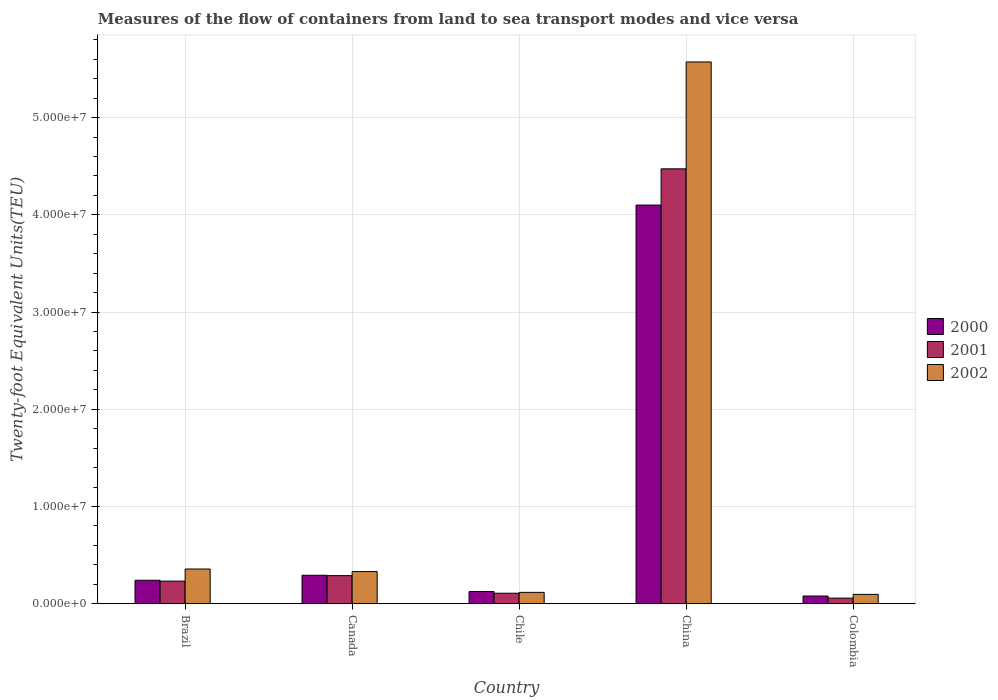Are the number of bars per tick equal to the number of legend labels?
Make the answer very short. Yes. How many bars are there on the 1st tick from the right?
Give a very brief answer. 3. What is the label of the 2nd group of bars from the left?
Keep it short and to the point. Canada. In how many cases, is the number of bars for a given country not equal to the number of legend labels?
Ensure brevity in your answer.  0. What is the container port traffic in 2000 in Brazil?
Provide a succinct answer. 2.41e+06. Across all countries, what is the maximum container port traffic in 2001?
Your answer should be compact. 4.47e+07. Across all countries, what is the minimum container port traffic in 2001?
Offer a terse response. 5.77e+05. In which country was the container port traffic in 2002 maximum?
Ensure brevity in your answer.  China. In which country was the container port traffic in 2002 minimum?
Your response must be concise. Colombia. What is the total container port traffic in 2002 in the graph?
Offer a terse response. 6.47e+07. What is the difference between the container port traffic in 2000 in China and that in Colombia?
Your answer should be very brief. 4.02e+07. What is the difference between the container port traffic in 2001 in Colombia and the container port traffic in 2000 in Chile?
Give a very brief answer. -6.76e+05. What is the average container port traffic in 2002 per country?
Give a very brief answer. 1.29e+07. What is the difference between the container port traffic of/in 2000 and container port traffic of/in 2001 in China?
Ensure brevity in your answer.  -3.73e+06. What is the ratio of the container port traffic in 2001 in Canada to that in Chile?
Your answer should be compact. 2.67. Is the difference between the container port traffic in 2000 in Chile and Colombia greater than the difference between the container port traffic in 2001 in Chile and Colombia?
Your answer should be very brief. No. What is the difference between the highest and the second highest container port traffic in 2000?
Your response must be concise. 3.86e+07. What is the difference between the highest and the lowest container port traffic in 2002?
Give a very brief answer. 5.48e+07. In how many countries, is the container port traffic in 2002 greater than the average container port traffic in 2002 taken over all countries?
Make the answer very short. 1. Is the sum of the container port traffic in 2000 in Chile and Colombia greater than the maximum container port traffic in 2001 across all countries?
Your answer should be very brief. No. Is it the case that in every country, the sum of the container port traffic in 2002 and container port traffic in 2000 is greater than the container port traffic in 2001?
Your response must be concise. Yes. How many bars are there?
Your response must be concise. 15. Are all the bars in the graph horizontal?
Give a very brief answer. No. How many countries are there in the graph?
Your answer should be compact. 5. Are the values on the major ticks of Y-axis written in scientific E-notation?
Give a very brief answer. Yes. How many legend labels are there?
Keep it short and to the point. 3. What is the title of the graph?
Provide a succinct answer. Measures of the flow of containers from land to sea transport modes and vice versa. Does "1984" appear as one of the legend labels in the graph?
Provide a short and direct response. No. What is the label or title of the Y-axis?
Offer a terse response. Twenty-foot Equivalent Units(TEU). What is the Twenty-foot Equivalent Units(TEU) of 2000 in Brazil?
Your answer should be very brief. 2.41e+06. What is the Twenty-foot Equivalent Units(TEU) in 2001 in Brazil?
Ensure brevity in your answer.  2.32e+06. What is the Twenty-foot Equivalent Units(TEU) of 2002 in Brazil?
Your answer should be very brief. 3.57e+06. What is the Twenty-foot Equivalent Units(TEU) of 2000 in Canada?
Your response must be concise. 2.93e+06. What is the Twenty-foot Equivalent Units(TEU) of 2001 in Canada?
Give a very brief answer. 2.89e+06. What is the Twenty-foot Equivalent Units(TEU) in 2002 in Canada?
Offer a terse response. 3.31e+06. What is the Twenty-foot Equivalent Units(TEU) of 2000 in Chile?
Keep it short and to the point. 1.25e+06. What is the Twenty-foot Equivalent Units(TEU) in 2001 in Chile?
Give a very brief answer. 1.08e+06. What is the Twenty-foot Equivalent Units(TEU) of 2002 in Chile?
Provide a short and direct response. 1.17e+06. What is the Twenty-foot Equivalent Units(TEU) of 2000 in China?
Make the answer very short. 4.10e+07. What is the Twenty-foot Equivalent Units(TEU) of 2001 in China?
Offer a very short reply. 4.47e+07. What is the Twenty-foot Equivalent Units(TEU) of 2002 in China?
Your answer should be very brief. 5.57e+07. What is the Twenty-foot Equivalent Units(TEU) of 2000 in Colombia?
Your answer should be very brief. 7.92e+05. What is the Twenty-foot Equivalent Units(TEU) of 2001 in Colombia?
Offer a very short reply. 5.77e+05. What is the Twenty-foot Equivalent Units(TEU) of 2002 in Colombia?
Provide a succinct answer. 9.61e+05. Across all countries, what is the maximum Twenty-foot Equivalent Units(TEU) of 2000?
Keep it short and to the point. 4.10e+07. Across all countries, what is the maximum Twenty-foot Equivalent Units(TEU) in 2001?
Offer a terse response. 4.47e+07. Across all countries, what is the maximum Twenty-foot Equivalent Units(TEU) of 2002?
Offer a very short reply. 5.57e+07. Across all countries, what is the minimum Twenty-foot Equivalent Units(TEU) of 2000?
Your response must be concise. 7.92e+05. Across all countries, what is the minimum Twenty-foot Equivalent Units(TEU) of 2001?
Your response must be concise. 5.77e+05. Across all countries, what is the minimum Twenty-foot Equivalent Units(TEU) of 2002?
Make the answer very short. 9.61e+05. What is the total Twenty-foot Equivalent Units(TEU) in 2000 in the graph?
Offer a very short reply. 4.84e+07. What is the total Twenty-foot Equivalent Units(TEU) of 2001 in the graph?
Provide a succinct answer. 5.16e+07. What is the total Twenty-foot Equivalent Units(TEU) in 2002 in the graph?
Give a very brief answer. 6.47e+07. What is the difference between the Twenty-foot Equivalent Units(TEU) in 2000 in Brazil and that in Canada?
Your answer should be compact. -5.15e+05. What is the difference between the Twenty-foot Equivalent Units(TEU) of 2001 in Brazil and that in Canada?
Provide a succinct answer. -5.67e+05. What is the difference between the Twenty-foot Equivalent Units(TEU) in 2002 in Brazil and that in Canada?
Ensure brevity in your answer.  2.63e+05. What is the difference between the Twenty-foot Equivalent Units(TEU) of 2000 in Brazil and that in Chile?
Provide a short and direct response. 1.16e+06. What is the difference between the Twenty-foot Equivalent Units(TEU) in 2001 in Brazil and that in Chile?
Your response must be concise. 1.24e+06. What is the difference between the Twenty-foot Equivalent Units(TEU) of 2002 in Brazil and that in Chile?
Ensure brevity in your answer.  2.40e+06. What is the difference between the Twenty-foot Equivalent Units(TEU) in 2000 in Brazil and that in China?
Make the answer very short. -3.86e+07. What is the difference between the Twenty-foot Equivalent Units(TEU) of 2001 in Brazil and that in China?
Make the answer very short. -4.24e+07. What is the difference between the Twenty-foot Equivalent Units(TEU) of 2002 in Brazil and that in China?
Ensure brevity in your answer.  -5.21e+07. What is the difference between the Twenty-foot Equivalent Units(TEU) in 2000 in Brazil and that in Colombia?
Provide a short and direct response. 1.62e+06. What is the difference between the Twenty-foot Equivalent Units(TEU) in 2001 in Brazil and that in Colombia?
Offer a terse response. 1.75e+06. What is the difference between the Twenty-foot Equivalent Units(TEU) in 2002 in Brazil and that in Colombia?
Your answer should be very brief. 2.61e+06. What is the difference between the Twenty-foot Equivalent Units(TEU) of 2000 in Canada and that in Chile?
Your answer should be compact. 1.67e+06. What is the difference between the Twenty-foot Equivalent Units(TEU) in 2001 in Canada and that in Chile?
Provide a succinct answer. 1.81e+06. What is the difference between the Twenty-foot Equivalent Units(TEU) in 2002 in Canada and that in Chile?
Make the answer very short. 2.14e+06. What is the difference between the Twenty-foot Equivalent Units(TEU) in 2000 in Canada and that in China?
Your response must be concise. -3.81e+07. What is the difference between the Twenty-foot Equivalent Units(TEU) in 2001 in Canada and that in China?
Give a very brief answer. -4.18e+07. What is the difference between the Twenty-foot Equivalent Units(TEU) in 2002 in Canada and that in China?
Provide a short and direct response. -5.24e+07. What is the difference between the Twenty-foot Equivalent Units(TEU) of 2000 in Canada and that in Colombia?
Ensure brevity in your answer.  2.14e+06. What is the difference between the Twenty-foot Equivalent Units(TEU) in 2001 in Canada and that in Colombia?
Give a very brief answer. 2.31e+06. What is the difference between the Twenty-foot Equivalent Units(TEU) of 2002 in Canada and that in Colombia?
Give a very brief answer. 2.35e+06. What is the difference between the Twenty-foot Equivalent Units(TEU) in 2000 in Chile and that in China?
Offer a very short reply. -3.97e+07. What is the difference between the Twenty-foot Equivalent Units(TEU) in 2001 in Chile and that in China?
Offer a terse response. -4.36e+07. What is the difference between the Twenty-foot Equivalent Units(TEU) of 2002 in Chile and that in China?
Your answer should be very brief. -5.45e+07. What is the difference between the Twenty-foot Equivalent Units(TEU) in 2000 in Chile and that in Colombia?
Your answer should be compact. 4.62e+05. What is the difference between the Twenty-foot Equivalent Units(TEU) in 2001 in Chile and that in Colombia?
Make the answer very short. 5.04e+05. What is the difference between the Twenty-foot Equivalent Units(TEU) in 2002 in Chile and that in Colombia?
Provide a short and direct response. 2.07e+05. What is the difference between the Twenty-foot Equivalent Units(TEU) of 2000 in China and that in Colombia?
Keep it short and to the point. 4.02e+07. What is the difference between the Twenty-foot Equivalent Units(TEU) of 2001 in China and that in Colombia?
Your answer should be compact. 4.41e+07. What is the difference between the Twenty-foot Equivalent Units(TEU) in 2002 in China and that in Colombia?
Offer a terse response. 5.48e+07. What is the difference between the Twenty-foot Equivalent Units(TEU) in 2000 in Brazil and the Twenty-foot Equivalent Units(TEU) in 2001 in Canada?
Your answer should be very brief. -4.77e+05. What is the difference between the Twenty-foot Equivalent Units(TEU) of 2000 in Brazil and the Twenty-foot Equivalent Units(TEU) of 2002 in Canada?
Provide a short and direct response. -8.94e+05. What is the difference between the Twenty-foot Equivalent Units(TEU) of 2001 in Brazil and the Twenty-foot Equivalent Units(TEU) of 2002 in Canada?
Provide a short and direct response. -9.84e+05. What is the difference between the Twenty-foot Equivalent Units(TEU) of 2000 in Brazil and the Twenty-foot Equivalent Units(TEU) of 2001 in Chile?
Your answer should be very brief. 1.33e+06. What is the difference between the Twenty-foot Equivalent Units(TEU) in 2000 in Brazil and the Twenty-foot Equivalent Units(TEU) in 2002 in Chile?
Make the answer very short. 1.25e+06. What is the difference between the Twenty-foot Equivalent Units(TEU) in 2001 in Brazil and the Twenty-foot Equivalent Units(TEU) in 2002 in Chile?
Ensure brevity in your answer.  1.16e+06. What is the difference between the Twenty-foot Equivalent Units(TEU) in 2000 in Brazil and the Twenty-foot Equivalent Units(TEU) in 2001 in China?
Ensure brevity in your answer.  -4.23e+07. What is the difference between the Twenty-foot Equivalent Units(TEU) of 2000 in Brazil and the Twenty-foot Equivalent Units(TEU) of 2002 in China?
Ensure brevity in your answer.  -5.33e+07. What is the difference between the Twenty-foot Equivalent Units(TEU) in 2001 in Brazil and the Twenty-foot Equivalent Units(TEU) in 2002 in China?
Give a very brief answer. -5.34e+07. What is the difference between the Twenty-foot Equivalent Units(TEU) in 2000 in Brazil and the Twenty-foot Equivalent Units(TEU) in 2001 in Colombia?
Your answer should be compact. 1.84e+06. What is the difference between the Twenty-foot Equivalent Units(TEU) of 2000 in Brazil and the Twenty-foot Equivalent Units(TEU) of 2002 in Colombia?
Offer a very short reply. 1.45e+06. What is the difference between the Twenty-foot Equivalent Units(TEU) of 2001 in Brazil and the Twenty-foot Equivalent Units(TEU) of 2002 in Colombia?
Ensure brevity in your answer.  1.36e+06. What is the difference between the Twenty-foot Equivalent Units(TEU) in 2000 in Canada and the Twenty-foot Equivalent Units(TEU) in 2001 in Chile?
Ensure brevity in your answer.  1.85e+06. What is the difference between the Twenty-foot Equivalent Units(TEU) of 2000 in Canada and the Twenty-foot Equivalent Units(TEU) of 2002 in Chile?
Your answer should be very brief. 1.76e+06. What is the difference between the Twenty-foot Equivalent Units(TEU) of 2001 in Canada and the Twenty-foot Equivalent Units(TEU) of 2002 in Chile?
Keep it short and to the point. 1.72e+06. What is the difference between the Twenty-foot Equivalent Units(TEU) in 2000 in Canada and the Twenty-foot Equivalent Units(TEU) in 2001 in China?
Give a very brief answer. -4.18e+07. What is the difference between the Twenty-foot Equivalent Units(TEU) in 2000 in Canada and the Twenty-foot Equivalent Units(TEU) in 2002 in China?
Make the answer very short. -5.28e+07. What is the difference between the Twenty-foot Equivalent Units(TEU) in 2001 in Canada and the Twenty-foot Equivalent Units(TEU) in 2002 in China?
Make the answer very short. -5.28e+07. What is the difference between the Twenty-foot Equivalent Units(TEU) in 2000 in Canada and the Twenty-foot Equivalent Units(TEU) in 2001 in Colombia?
Provide a short and direct response. 2.35e+06. What is the difference between the Twenty-foot Equivalent Units(TEU) of 2000 in Canada and the Twenty-foot Equivalent Units(TEU) of 2002 in Colombia?
Your answer should be very brief. 1.97e+06. What is the difference between the Twenty-foot Equivalent Units(TEU) of 2001 in Canada and the Twenty-foot Equivalent Units(TEU) of 2002 in Colombia?
Provide a short and direct response. 1.93e+06. What is the difference between the Twenty-foot Equivalent Units(TEU) of 2000 in Chile and the Twenty-foot Equivalent Units(TEU) of 2001 in China?
Offer a terse response. -4.35e+07. What is the difference between the Twenty-foot Equivalent Units(TEU) in 2000 in Chile and the Twenty-foot Equivalent Units(TEU) in 2002 in China?
Your answer should be very brief. -5.45e+07. What is the difference between the Twenty-foot Equivalent Units(TEU) of 2001 in Chile and the Twenty-foot Equivalent Units(TEU) of 2002 in China?
Provide a short and direct response. -5.46e+07. What is the difference between the Twenty-foot Equivalent Units(TEU) of 2000 in Chile and the Twenty-foot Equivalent Units(TEU) of 2001 in Colombia?
Keep it short and to the point. 6.76e+05. What is the difference between the Twenty-foot Equivalent Units(TEU) of 2000 in Chile and the Twenty-foot Equivalent Units(TEU) of 2002 in Colombia?
Provide a succinct answer. 2.92e+05. What is the difference between the Twenty-foot Equivalent Units(TEU) in 2001 in Chile and the Twenty-foot Equivalent Units(TEU) in 2002 in Colombia?
Provide a succinct answer. 1.20e+05. What is the difference between the Twenty-foot Equivalent Units(TEU) of 2000 in China and the Twenty-foot Equivalent Units(TEU) of 2001 in Colombia?
Your answer should be compact. 4.04e+07. What is the difference between the Twenty-foot Equivalent Units(TEU) of 2000 in China and the Twenty-foot Equivalent Units(TEU) of 2002 in Colombia?
Give a very brief answer. 4.00e+07. What is the difference between the Twenty-foot Equivalent Units(TEU) in 2001 in China and the Twenty-foot Equivalent Units(TEU) in 2002 in Colombia?
Your answer should be compact. 4.38e+07. What is the average Twenty-foot Equivalent Units(TEU) in 2000 per country?
Your answer should be compact. 9.68e+06. What is the average Twenty-foot Equivalent Units(TEU) of 2001 per country?
Provide a succinct answer. 1.03e+07. What is the average Twenty-foot Equivalent Units(TEU) in 2002 per country?
Your response must be concise. 1.29e+07. What is the difference between the Twenty-foot Equivalent Units(TEU) in 2000 and Twenty-foot Equivalent Units(TEU) in 2001 in Brazil?
Give a very brief answer. 8.93e+04. What is the difference between the Twenty-foot Equivalent Units(TEU) in 2000 and Twenty-foot Equivalent Units(TEU) in 2002 in Brazil?
Ensure brevity in your answer.  -1.16e+06. What is the difference between the Twenty-foot Equivalent Units(TEU) of 2001 and Twenty-foot Equivalent Units(TEU) of 2002 in Brazil?
Provide a succinct answer. -1.25e+06. What is the difference between the Twenty-foot Equivalent Units(TEU) in 2000 and Twenty-foot Equivalent Units(TEU) in 2001 in Canada?
Offer a very short reply. 3.76e+04. What is the difference between the Twenty-foot Equivalent Units(TEU) in 2000 and Twenty-foot Equivalent Units(TEU) in 2002 in Canada?
Your answer should be very brief. -3.79e+05. What is the difference between the Twenty-foot Equivalent Units(TEU) of 2001 and Twenty-foot Equivalent Units(TEU) of 2002 in Canada?
Offer a terse response. -4.17e+05. What is the difference between the Twenty-foot Equivalent Units(TEU) of 2000 and Twenty-foot Equivalent Units(TEU) of 2001 in Chile?
Give a very brief answer. 1.73e+05. What is the difference between the Twenty-foot Equivalent Units(TEU) in 2000 and Twenty-foot Equivalent Units(TEU) in 2002 in Chile?
Offer a terse response. 8.53e+04. What is the difference between the Twenty-foot Equivalent Units(TEU) of 2001 and Twenty-foot Equivalent Units(TEU) of 2002 in Chile?
Keep it short and to the point. -8.73e+04. What is the difference between the Twenty-foot Equivalent Units(TEU) in 2000 and Twenty-foot Equivalent Units(TEU) in 2001 in China?
Ensure brevity in your answer.  -3.73e+06. What is the difference between the Twenty-foot Equivalent Units(TEU) of 2000 and Twenty-foot Equivalent Units(TEU) of 2002 in China?
Your answer should be compact. -1.47e+07. What is the difference between the Twenty-foot Equivalent Units(TEU) in 2001 and Twenty-foot Equivalent Units(TEU) in 2002 in China?
Ensure brevity in your answer.  -1.10e+07. What is the difference between the Twenty-foot Equivalent Units(TEU) in 2000 and Twenty-foot Equivalent Units(TEU) in 2001 in Colombia?
Ensure brevity in your answer.  2.15e+05. What is the difference between the Twenty-foot Equivalent Units(TEU) of 2000 and Twenty-foot Equivalent Units(TEU) of 2002 in Colombia?
Your response must be concise. -1.69e+05. What is the difference between the Twenty-foot Equivalent Units(TEU) of 2001 and Twenty-foot Equivalent Units(TEU) of 2002 in Colombia?
Your answer should be very brief. -3.84e+05. What is the ratio of the Twenty-foot Equivalent Units(TEU) of 2000 in Brazil to that in Canada?
Offer a very short reply. 0.82. What is the ratio of the Twenty-foot Equivalent Units(TEU) of 2001 in Brazil to that in Canada?
Your response must be concise. 0.8. What is the ratio of the Twenty-foot Equivalent Units(TEU) of 2002 in Brazil to that in Canada?
Provide a short and direct response. 1.08. What is the ratio of the Twenty-foot Equivalent Units(TEU) of 2000 in Brazil to that in Chile?
Keep it short and to the point. 1.93. What is the ratio of the Twenty-foot Equivalent Units(TEU) of 2001 in Brazil to that in Chile?
Your response must be concise. 2.15. What is the ratio of the Twenty-foot Equivalent Units(TEU) in 2002 in Brazil to that in Chile?
Offer a terse response. 3.06. What is the ratio of the Twenty-foot Equivalent Units(TEU) in 2000 in Brazil to that in China?
Make the answer very short. 0.06. What is the ratio of the Twenty-foot Equivalent Units(TEU) of 2001 in Brazil to that in China?
Offer a terse response. 0.05. What is the ratio of the Twenty-foot Equivalent Units(TEU) of 2002 in Brazil to that in China?
Offer a very short reply. 0.06. What is the ratio of the Twenty-foot Equivalent Units(TEU) of 2000 in Brazil to that in Colombia?
Make the answer very short. 3.05. What is the ratio of the Twenty-foot Equivalent Units(TEU) of 2001 in Brazil to that in Colombia?
Provide a succinct answer. 4.03. What is the ratio of the Twenty-foot Equivalent Units(TEU) in 2002 in Brazil to that in Colombia?
Your response must be concise. 3.72. What is the ratio of the Twenty-foot Equivalent Units(TEU) of 2000 in Canada to that in Chile?
Keep it short and to the point. 2.34. What is the ratio of the Twenty-foot Equivalent Units(TEU) in 2001 in Canada to that in Chile?
Give a very brief answer. 2.67. What is the ratio of the Twenty-foot Equivalent Units(TEU) in 2002 in Canada to that in Chile?
Make the answer very short. 2.83. What is the ratio of the Twenty-foot Equivalent Units(TEU) in 2000 in Canada to that in China?
Offer a very short reply. 0.07. What is the ratio of the Twenty-foot Equivalent Units(TEU) of 2001 in Canada to that in China?
Your answer should be very brief. 0.06. What is the ratio of the Twenty-foot Equivalent Units(TEU) in 2002 in Canada to that in China?
Keep it short and to the point. 0.06. What is the ratio of the Twenty-foot Equivalent Units(TEU) in 2000 in Canada to that in Colombia?
Your response must be concise. 3.7. What is the ratio of the Twenty-foot Equivalent Units(TEU) in 2001 in Canada to that in Colombia?
Offer a very short reply. 5.01. What is the ratio of the Twenty-foot Equivalent Units(TEU) of 2002 in Canada to that in Colombia?
Give a very brief answer. 3.44. What is the ratio of the Twenty-foot Equivalent Units(TEU) in 2000 in Chile to that in China?
Your answer should be very brief. 0.03. What is the ratio of the Twenty-foot Equivalent Units(TEU) in 2001 in Chile to that in China?
Provide a short and direct response. 0.02. What is the ratio of the Twenty-foot Equivalent Units(TEU) of 2002 in Chile to that in China?
Ensure brevity in your answer.  0.02. What is the ratio of the Twenty-foot Equivalent Units(TEU) of 2000 in Chile to that in Colombia?
Make the answer very short. 1.58. What is the ratio of the Twenty-foot Equivalent Units(TEU) in 2001 in Chile to that in Colombia?
Your answer should be very brief. 1.87. What is the ratio of the Twenty-foot Equivalent Units(TEU) in 2002 in Chile to that in Colombia?
Offer a terse response. 1.22. What is the ratio of the Twenty-foot Equivalent Units(TEU) of 2000 in China to that in Colombia?
Keep it short and to the point. 51.79. What is the ratio of the Twenty-foot Equivalent Units(TEU) of 2001 in China to that in Colombia?
Ensure brevity in your answer.  77.51. What is the ratio of the Twenty-foot Equivalent Units(TEU) in 2002 in China to that in Colombia?
Your response must be concise. 58. What is the difference between the highest and the second highest Twenty-foot Equivalent Units(TEU) of 2000?
Your answer should be very brief. 3.81e+07. What is the difference between the highest and the second highest Twenty-foot Equivalent Units(TEU) in 2001?
Keep it short and to the point. 4.18e+07. What is the difference between the highest and the second highest Twenty-foot Equivalent Units(TEU) in 2002?
Provide a succinct answer. 5.21e+07. What is the difference between the highest and the lowest Twenty-foot Equivalent Units(TEU) of 2000?
Make the answer very short. 4.02e+07. What is the difference between the highest and the lowest Twenty-foot Equivalent Units(TEU) in 2001?
Ensure brevity in your answer.  4.41e+07. What is the difference between the highest and the lowest Twenty-foot Equivalent Units(TEU) in 2002?
Keep it short and to the point. 5.48e+07. 